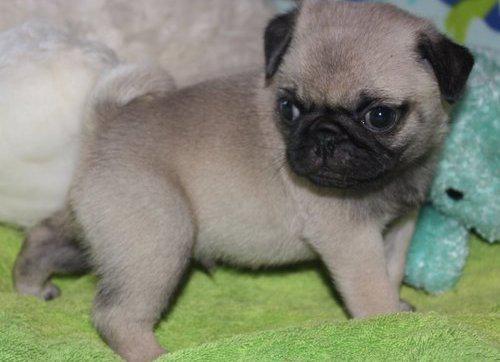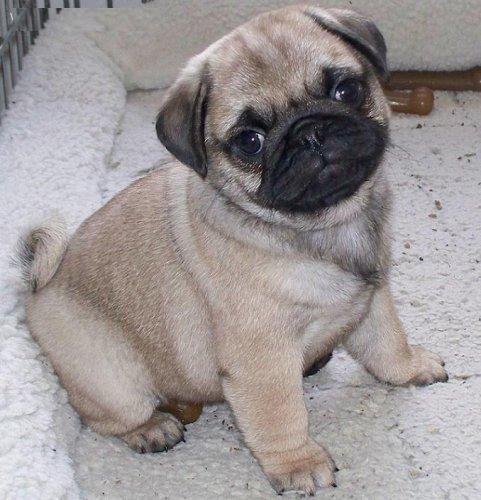The first image is the image on the left, the second image is the image on the right. Considering the images on both sides, is "Exactly one dog is in the grass." valid? Answer yes or no. No. The first image is the image on the left, the second image is the image on the right. For the images displayed, is the sentence "Each image shows one pug posed outdoors, and one image shows a standing pug while the other shows a reclining pug." factually correct? Answer yes or no. No. 